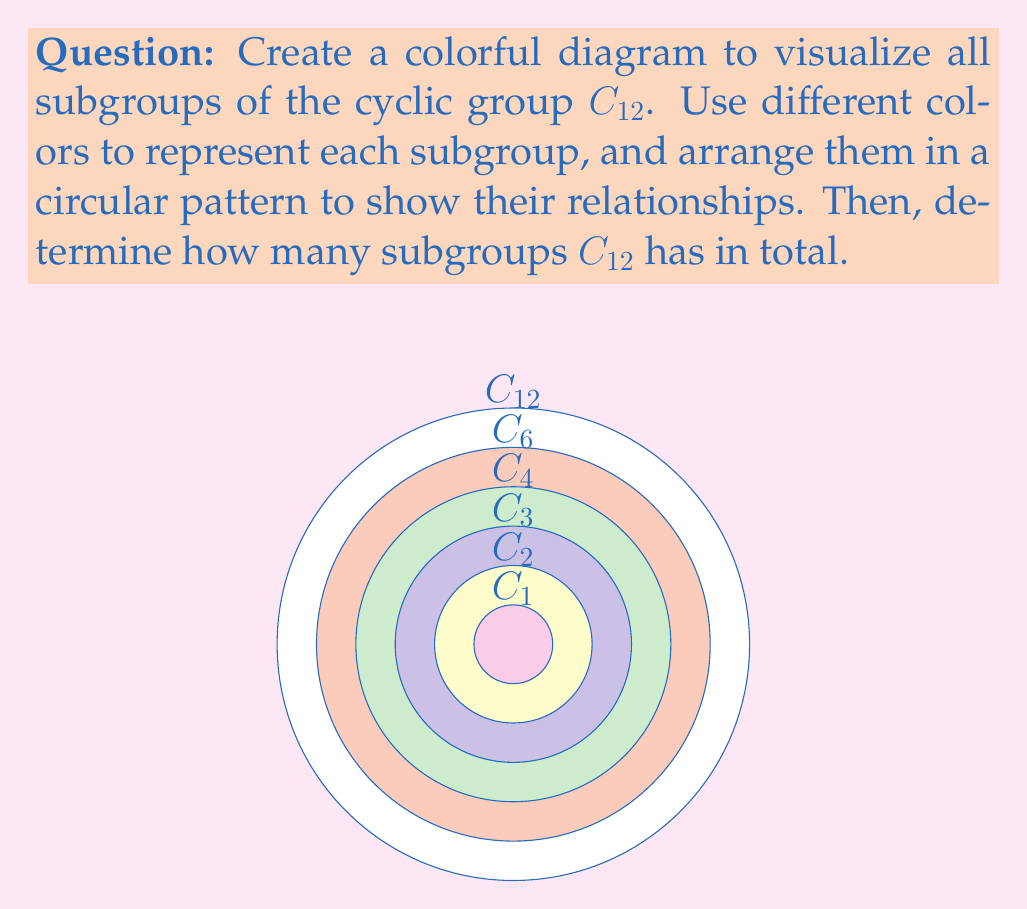Teach me how to tackle this problem. To solve this problem, let's follow these steps:

1) First, recall that the subgroups of a cyclic group $C_n$ are precisely the cyclic groups $C_d$ where $d$ divides $n$.

2) To find the subgroups of $C_{12}$, we need to find all divisors of 12:
   The divisors of 12 are 1, 2, 3, 4, 6, and 12.

3) This means that $C_{12}$ has the following subgroups:
   $C_1$, $C_2$, $C_3$, $C_4$, $C_6$, and $C_{12}$ (the group itself is always a subgroup)

4) In the diagram, we've represented these subgroups as concentric circles:
   - The outermost circle (white) represents $C_{12}$
   - The pink circle represents $C_6$
   - The light green circle represents $C_4$
   - The light blue circle represents $C_3$
   - The yellow circle represents $C_2$
   - The innermost purple circle represents $C_1$

5) This circular arrangement visually demonstrates the inclusion relationships between the subgroups. Each subgroup is contained within the subgroups represented by larger circles.

6) To count the total number of subgroups, we simply need to count the number of divisors of 12, which we found in step 2.

Therefore, $C_{12}$ has 6 subgroups in total.
Answer: 6 subgroups 